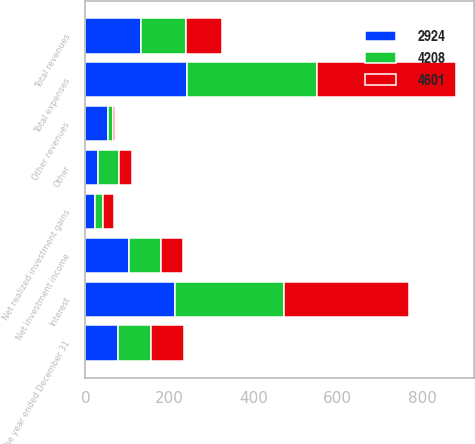Convert chart to OTSL. <chart><loc_0><loc_0><loc_500><loc_500><stacked_bar_chart><ecel><fcel>For the year ended December 31<fcel>Net investment income<fcel>Net realized investment gains<fcel>Other revenues<fcel>Total revenues<fcel>Interest<fcel>Other<fcel>Total expenses<nl><fcel>4601<fcel>78<fcel>52<fcel>27<fcel>5<fcel>84<fcel>297<fcel>32<fcel>329<nl><fcel>4208<fcel>78<fcel>78<fcel>17<fcel>12<fcel>107<fcel>260<fcel>50<fcel>310<nl><fcel>2924<fcel>78<fcel>103<fcel>24<fcel>54<fcel>133<fcel>212<fcel>29<fcel>241<nl></chart> 